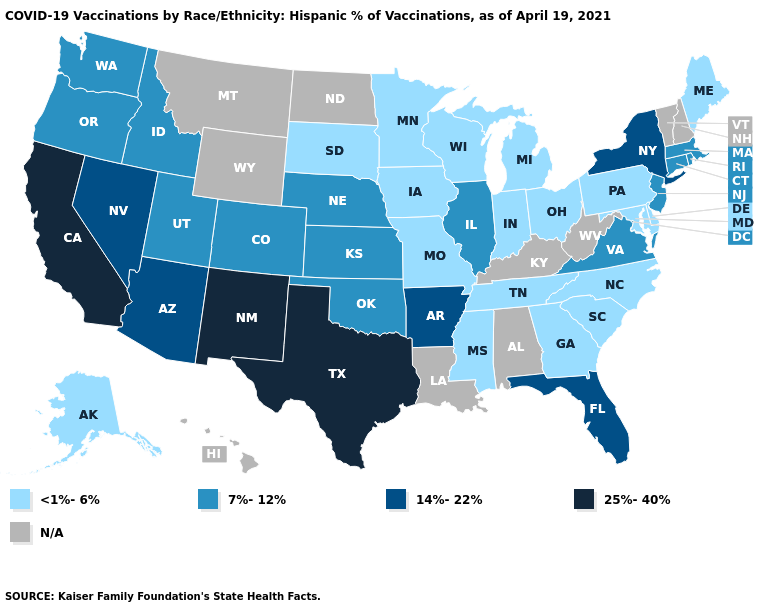Does Kansas have the highest value in the MidWest?
Be succinct. Yes. What is the lowest value in the USA?
Write a very short answer. <1%-6%. What is the value of Louisiana?
Write a very short answer. N/A. Name the states that have a value in the range <1%-6%?
Write a very short answer. Alaska, Delaware, Georgia, Indiana, Iowa, Maine, Maryland, Michigan, Minnesota, Mississippi, Missouri, North Carolina, Ohio, Pennsylvania, South Carolina, South Dakota, Tennessee, Wisconsin. How many symbols are there in the legend?
Keep it brief. 5. Is the legend a continuous bar?
Answer briefly. No. Does the first symbol in the legend represent the smallest category?
Give a very brief answer. Yes. Name the states that have a value in the range N/A?
Concise answer only. Alabama, Hawaii, Kentucky, Louisiana, Montana, New Hampshire, North Dakota, Vermont, West Virginia, Wyoming. What is the value of Alaska?
Give a very brief answer. <1%-6%. Does Alaska have the lowest value in the West?
Concise answer only. Yes. What is the highest value in the USA?
Short answer required. 25%-40%. Which states hav the highest value in the Northeast?
Keep it brief. New York. Name the states that have a value in the range 7%-12%?
Short answer required. Colorado, Connecticut, Idaho, Illinois, Kansas, Massachusetts, Nebraska, New Jersey, Oklahoma, Oregon, Rhode Island, Utah, Virginia, Washington. 